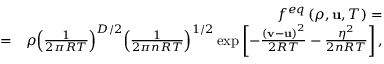<formula> <loc_0><loc_0><loc_500><loc_500>\begin{array} { r l r } & { { f ^ { e q } } \left ( { \rho , { u } , T } \right ) = } \\ & { = } & { \rho { \left ( { \frac { 1 } { 2 \pi R T } } \right ) ^ { D / 2 } } { \left ( { \frac { 1 } { 2 \pi n R T } } \right ) ^ { 1 / 2 } } \exp \left [ { - \frac { { { { \left ( { { v } - { u } } \right ) } ^ { 2 } } } } { 2 R T } - \frac { { { \eta ^ { 2 } } } } { 2 n R T } } \right ] , } \end{array}</formula> 